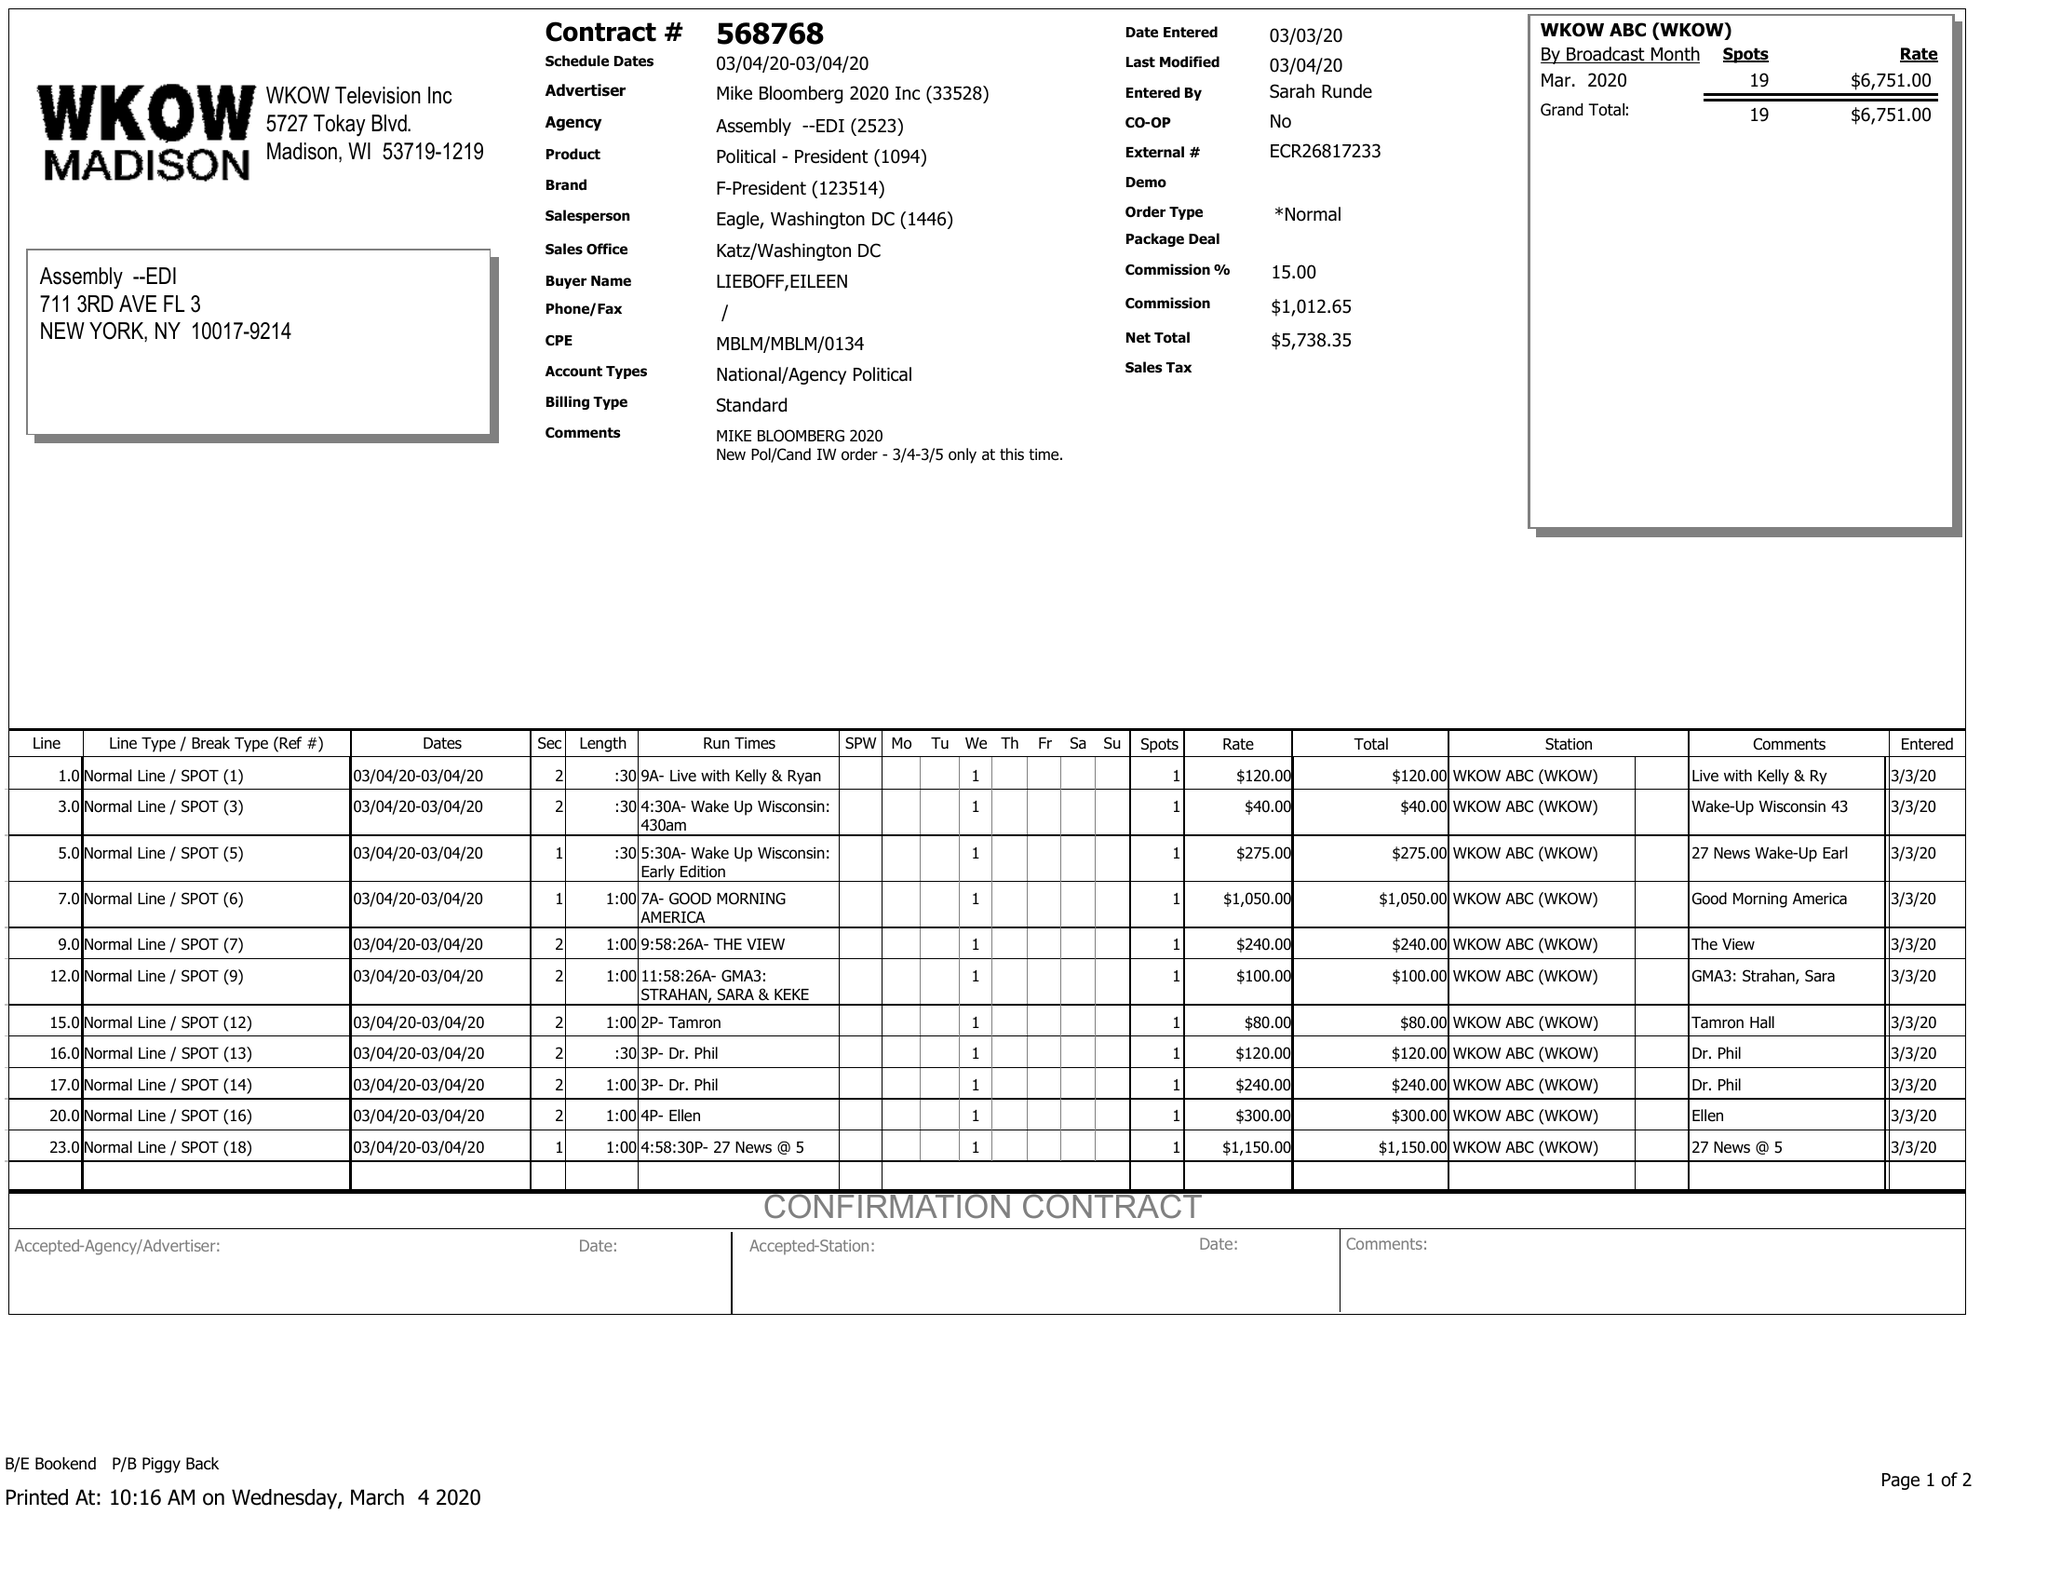What is the value for the gross_amount?
Answer the question using a single word or phrase. 6751.00 